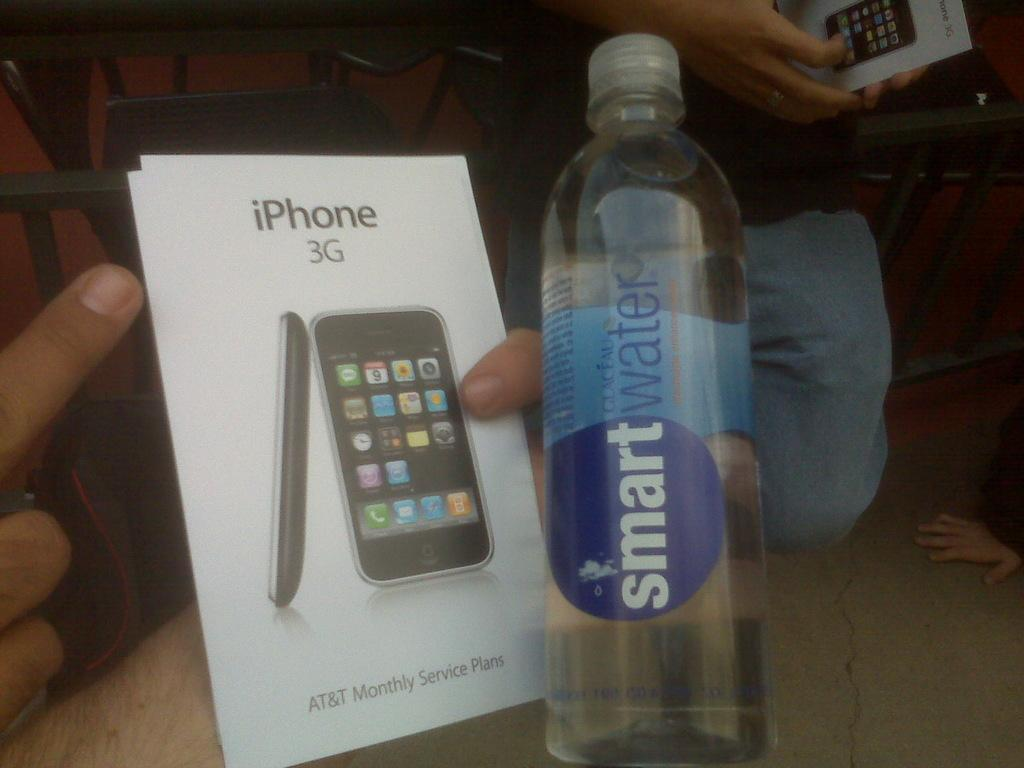<image>
Present a compact description of the photo's key features. some smart water next to an iPhone booklet 